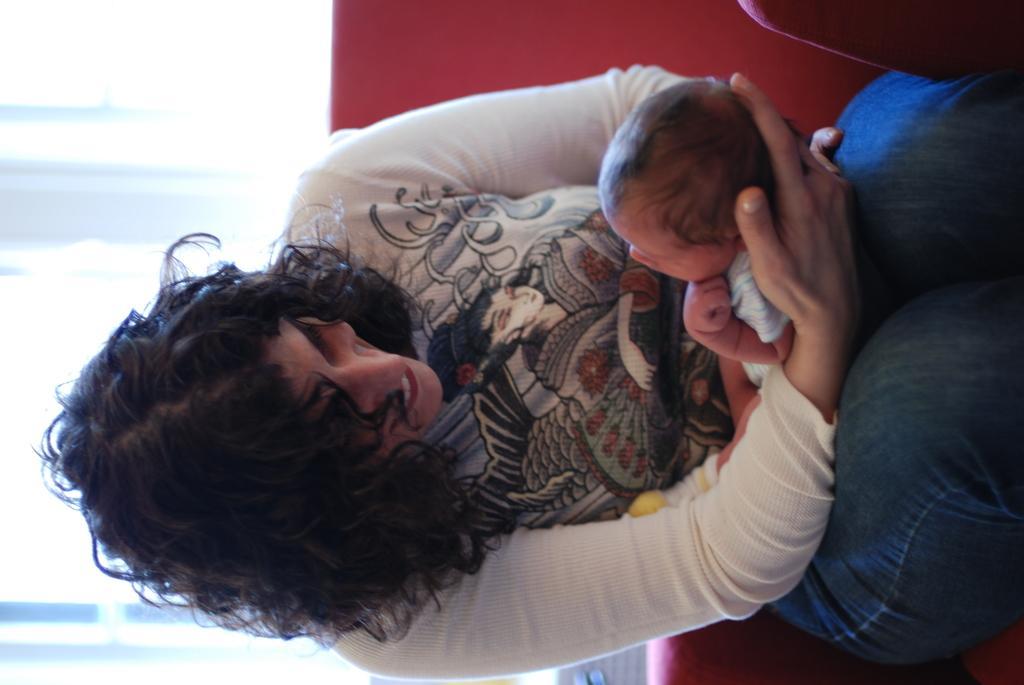How would you summarize this image in a sentence or two? In the center of the image there is a lady holding a baby in her hand sitting on a red color sofa 